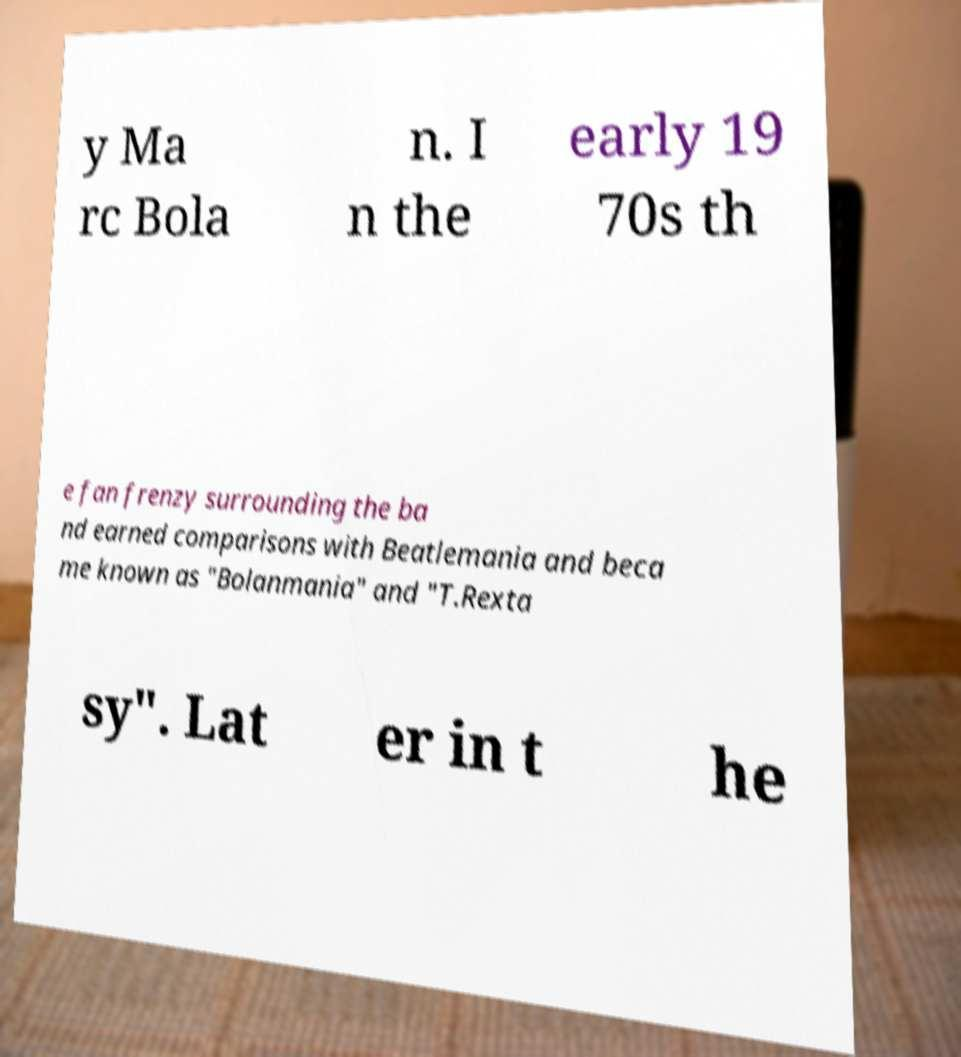Can you read and provide the text displayed in the image?This photo seems to have some interesting text. Can you extract and type it out for me? y Ma rc Bola n. I n the early 19 70s th e fan frenzy surrounding the ba nd earned comparisons with Beatlemania and beca me known as "Bolanmania" and "T.Rexta sy". Lat er in t he 